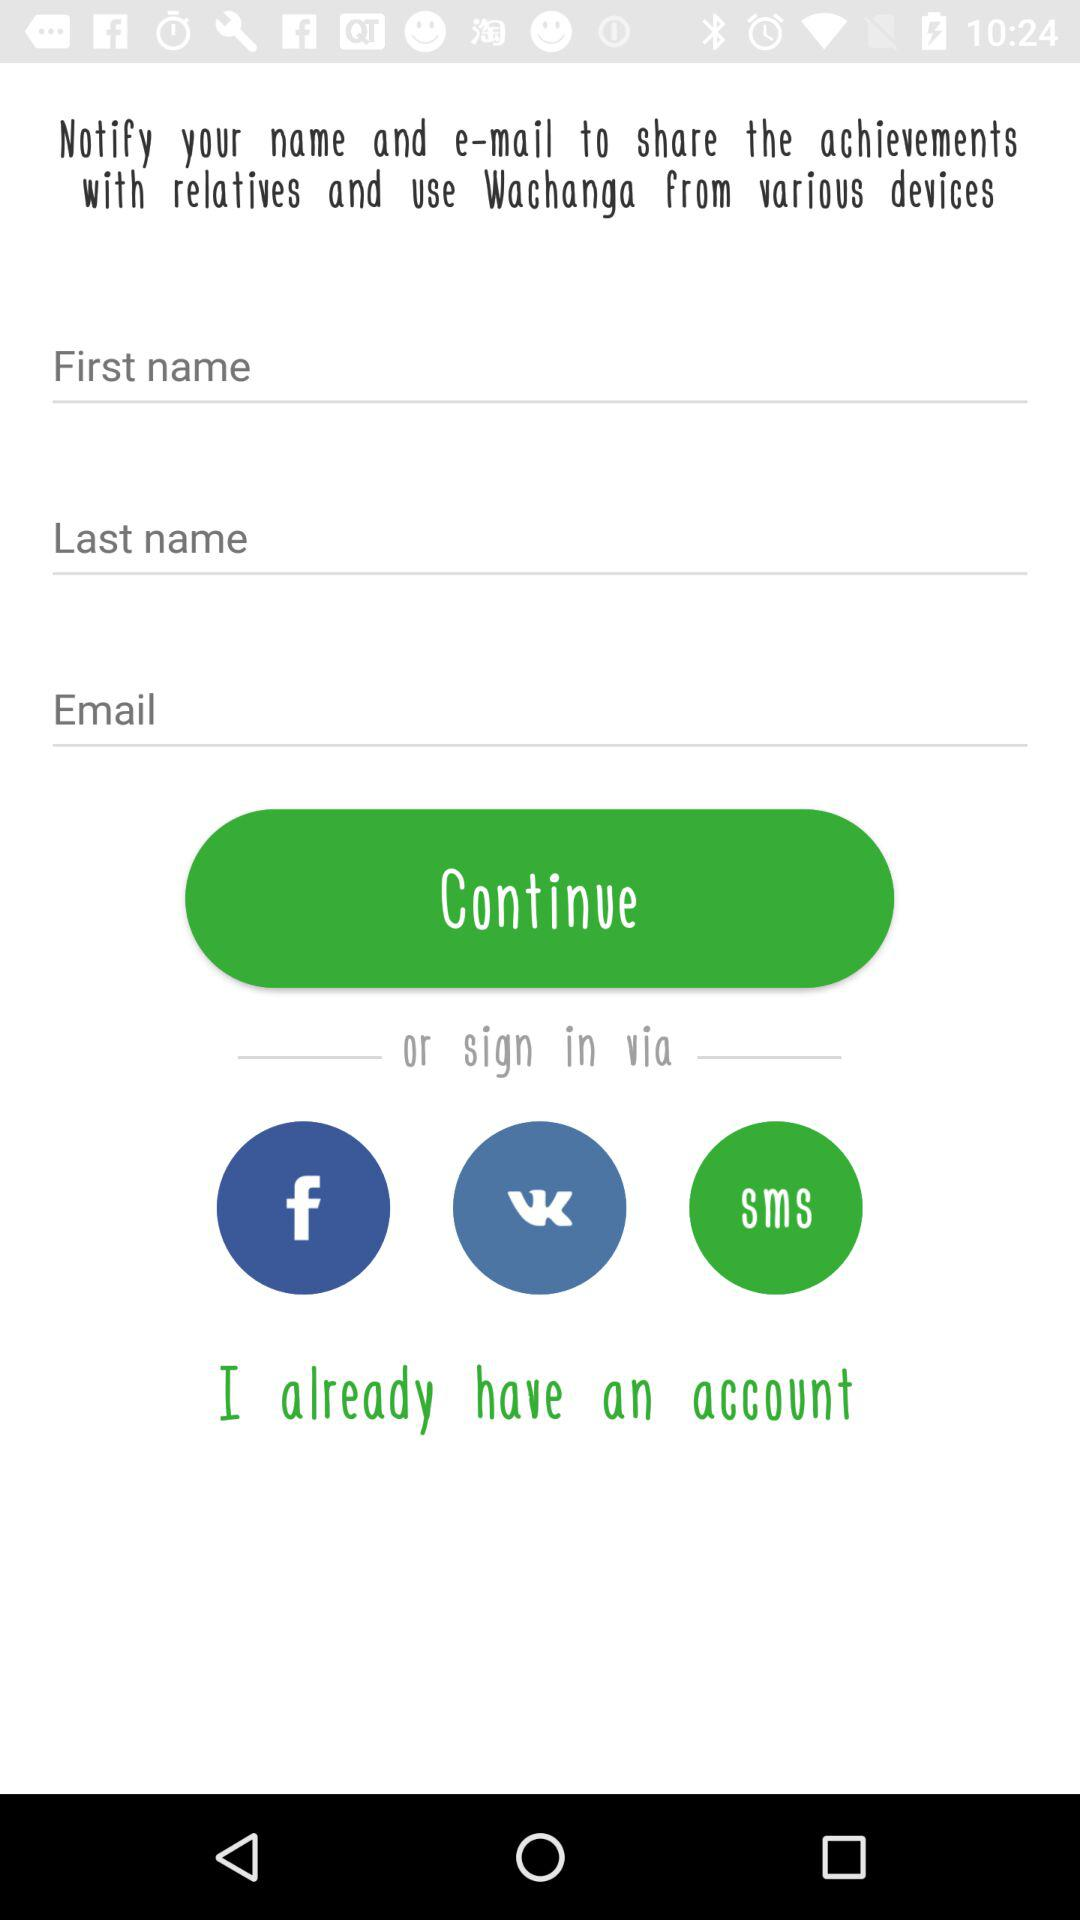How many text inputs are there for entering user information?
Answer the question using a single word or phrase. 3 